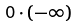<formula> <loc_0><loc_0><loc_500><loc_500>0 \cdot ( - \infty )</formula> 